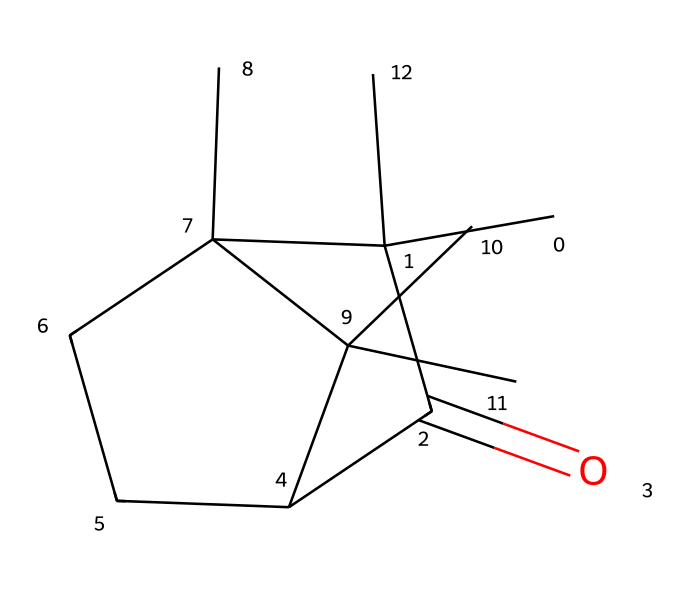How many carbon atoms are in camphor? The SMILES representation indicates a total of 10 carbon atoms, as each carbon is represented as 'C' in the structure and counted from the sequence of the chemical.
Answer: 10 What is the functional group present in camphor? The structure indicates a carbonyl group (C=O) due to the presence of the double bond between carbon and oxygen within the molecular formula.
Answer: carbonyl How many rings are present in camphor's structure? Analyzing the chemical structure reveals two cycles within the arrangement of carbon atoms, indicating the presence of two rings.
Answer: 2 What is the degree of saturation in this molecule? The degree of saturation can be calculated by considering the number of cyclic and double-bonded structures present, which together lead to a saturation count of 4.
Answer: 4 Is camphor polar or non-polar? The functional groups and molecular structure suggest that camphor exhibits both polar and non-polar characteristics, which overall categorize it as non-polar due to its hydrocarbon nature.
Answer: non-polar 